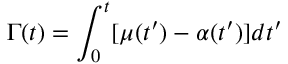<formula> <loc_0><loc_0><loc_500><loc_500>\Gamma ( t ) = \int _ { 0 } ^ { t } [ \mu ( t ^ { \prime } ) - \alpha ( t ^ { \prime } ) ] d t ^ { \prime }</formula> 